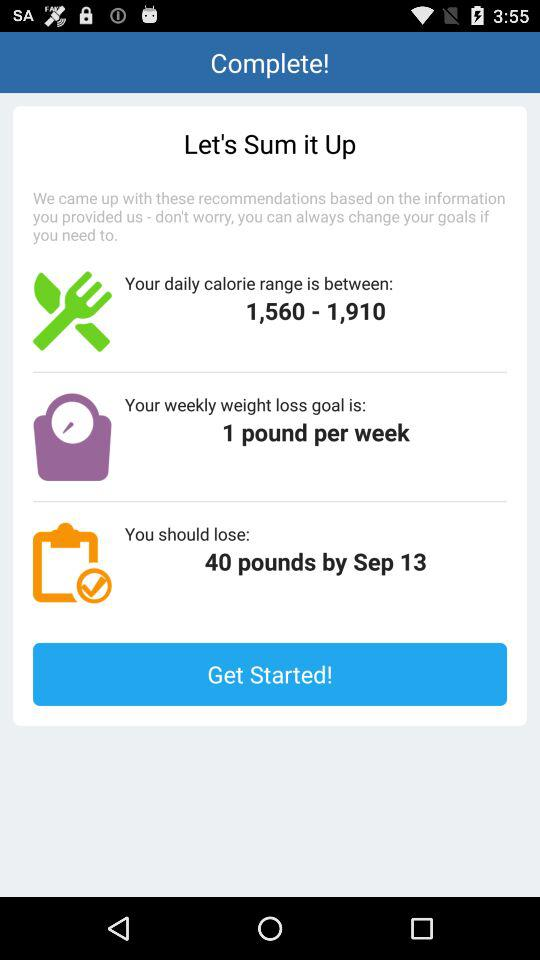What is the daily calorie range here? The daily calorie range is from 1,560 to 1,910. 